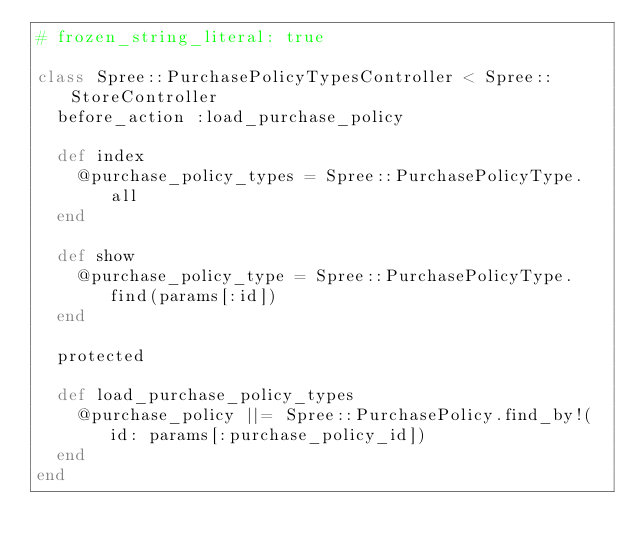Convert code to text. <code><loc_0><loc_0><loc_500><loc_500><_Ruby_># frozen_string_literal: true

class Spree::PurchasePolicyTypesController < Spree::StoreController
  before_action :load_purchase_policy

  def index
    @purchase_policy_types = Spree::PurchasePolicyType.all
  end

  def show
    @purchase_policy_type = Spree::PurchasePolicyType.find(params[:id])
  end

  protected

  def load_purchase_policy_types
    @purchase_policy ||= Spree::PurchasePolicy.find_by!(id: params[:purchase_policy_id])
  end
end
</code> 